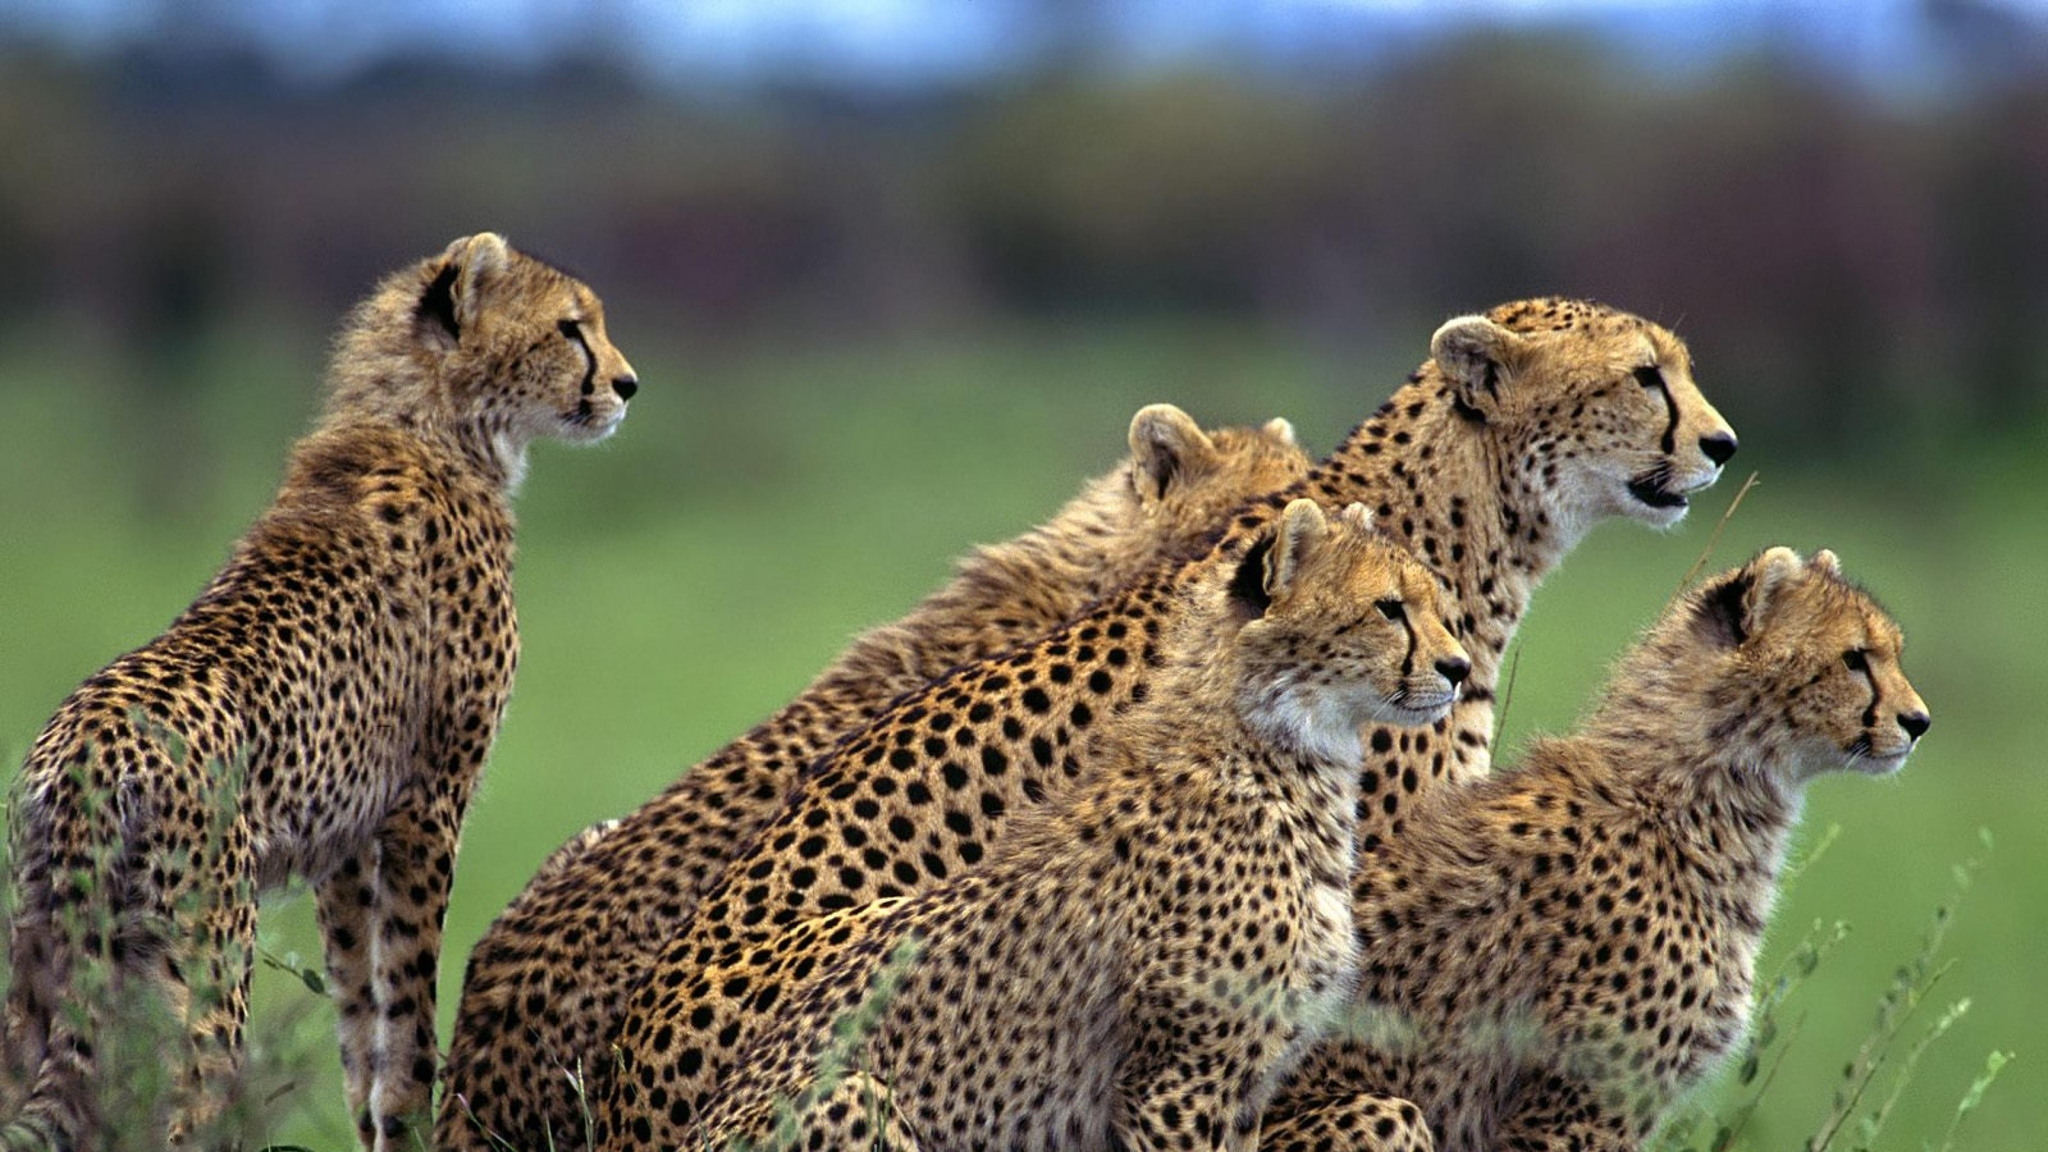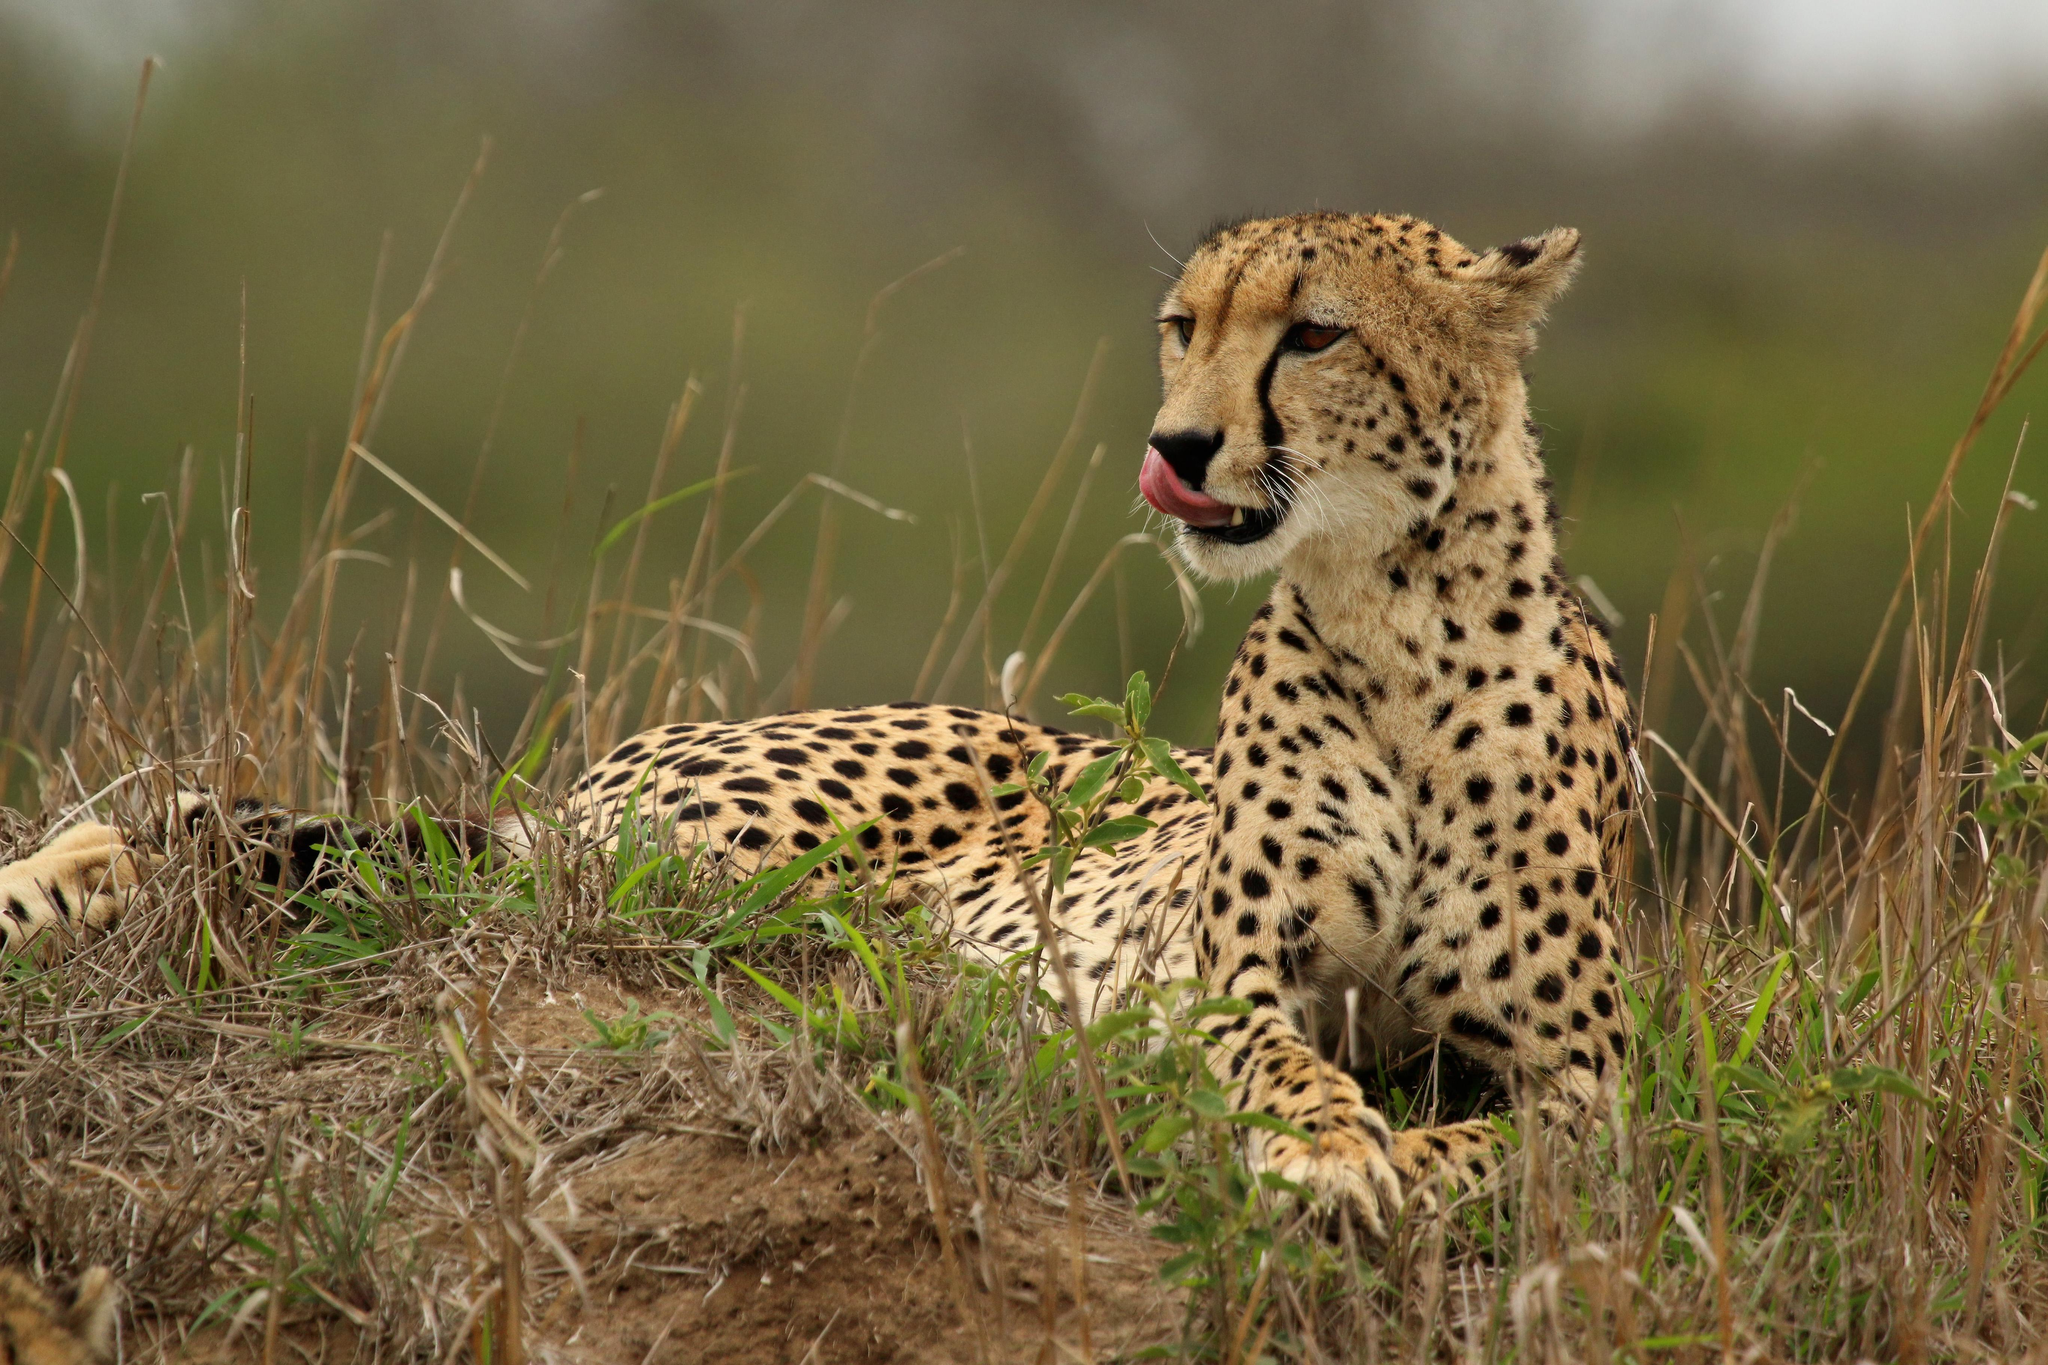The first image is the image on the left, the second image is the image on the right. Assess this claim about the two images: "There are five animals in the image on the right.". Correct or not? Answer yes or no. No. 